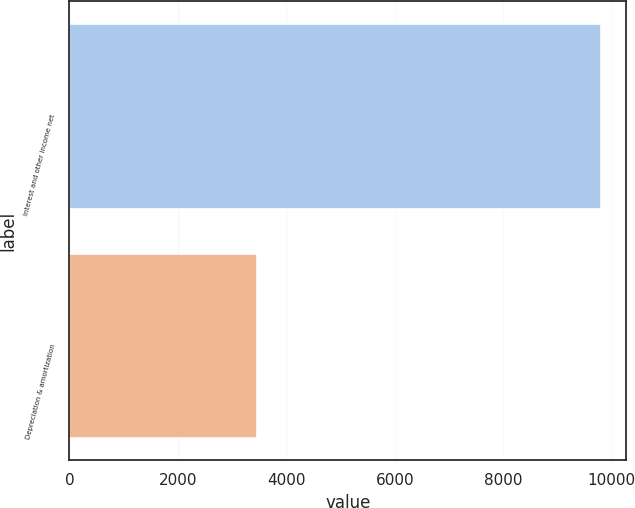Convert chart. <chart><loc_0><loc_0><loc_500><loc_500><bar_chart><fcel>Interest and other income net<fcel>Depreciation & amortization<nl><fcel>9775<fcel>3446<nl></chart> 